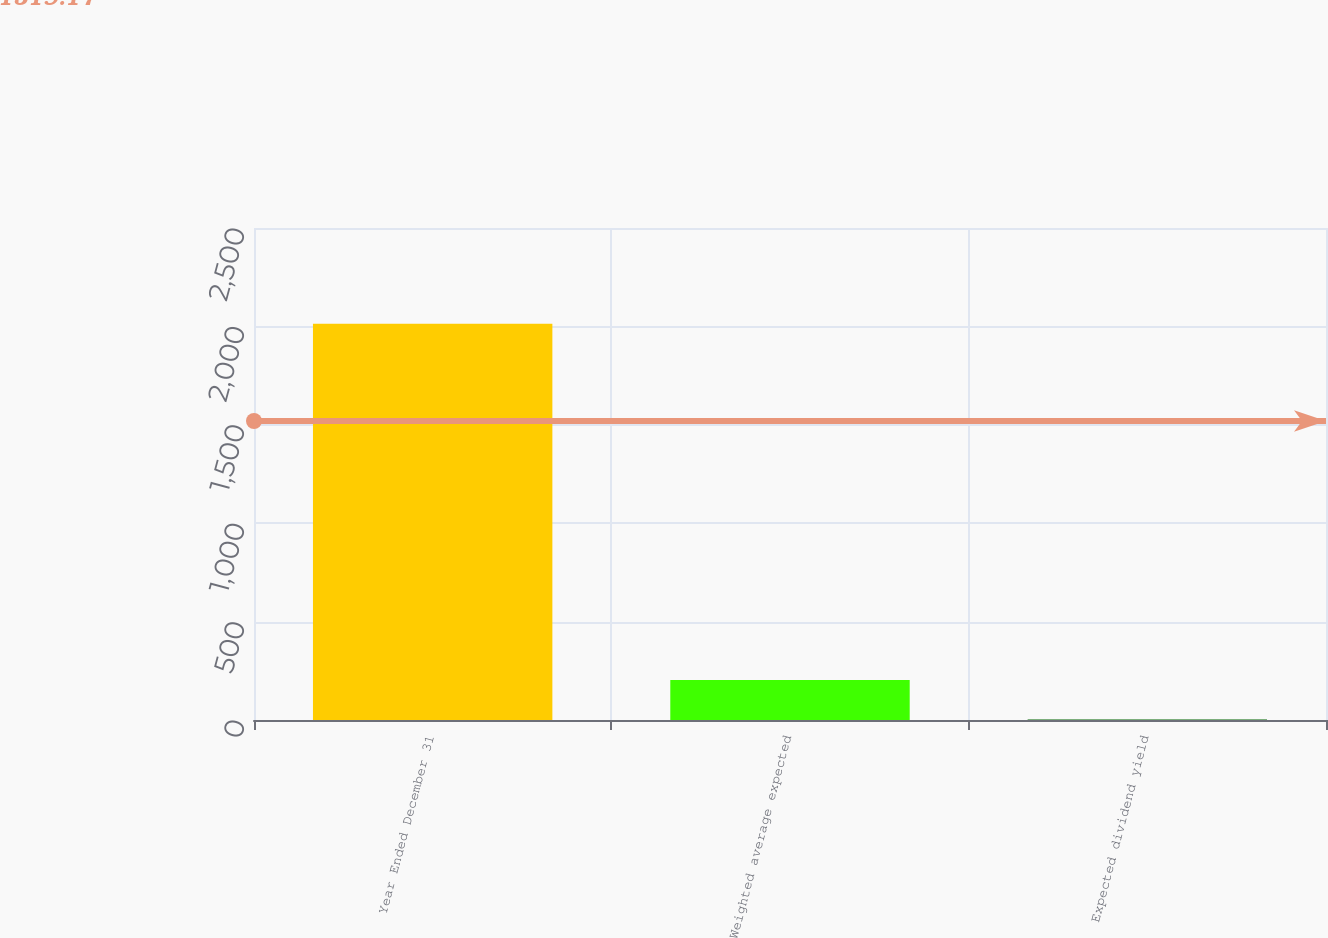Convert chart to OTSL. <chart><loc_0><loc_0><loc_500><loc_500><bar_chart><fcel>Year Ended December 31<fcel>Weighted average expected<fcel>Expected dividend yield<nl><fcel>2014<fcel>203.65<fcel>2.5<nl></chart> 